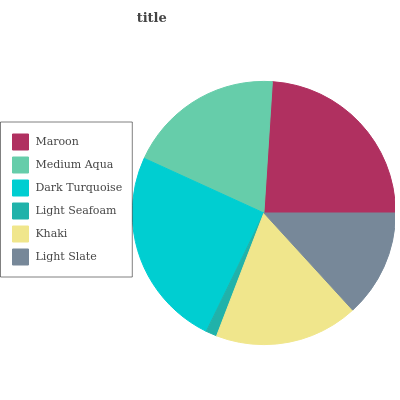Is Light Seafoam the minimum?
Answer yes or no. Yes. Is Dark Turquoise the maximum?
Answer yes or no. Yes. Is Medium Aqua the minimum?
Answer yes or no. No. Is Medium Aqua the maximum?
Answer yes or no. No. Is Maroon greater than Medium Aqua?
Answer yes or no. Yes. Is Medium Aqua less than Maroon?
Answer yes or no. Yes. Is Medium Aqua greater than Maroon?
Answer yes or no. No. Is Maroon less than Medium Aqua?
Answer yes or no. No. Is Medium Aqua the high median?
Answer yes or no. Yes. Is Khaki the low median?
Answer yes or no. Yes. Is Dark Turquoise the high median?
Answer yes or no. No. Is Medium Aqua the low median?
Answer yes or no. No. 